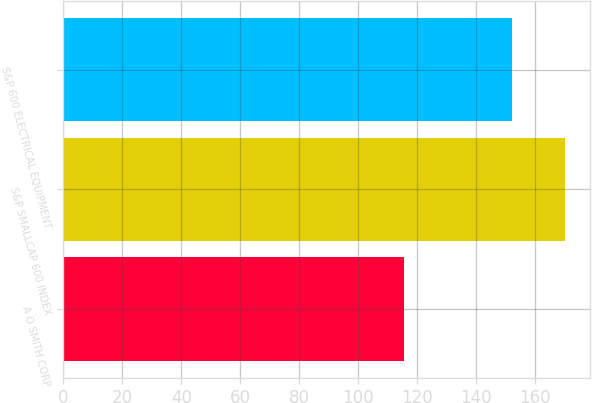Convert chart. <chart><loc_0><loc_0><loc_500><loc_500><bar_chart><fcel>A O SMITH CORP<fcel>S&P SMALLCAP 600 INDEX<fcel>S&P 600 ELECTRICAL EQUIPMENT<nl><fcel>115.36<fcel>170.22<fcel>152.18<nl></chart> 